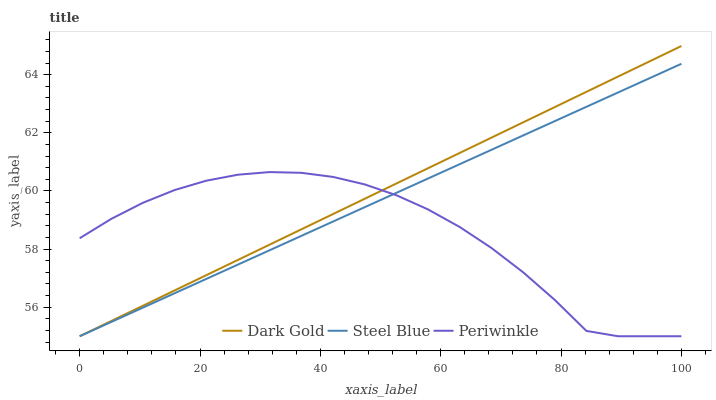Does Periwinkle have the minimum area under the curve?
Answer yes or no. Yes. Does Dark Gold have the maximum area under the curve?
Answer yes or no. Yes. Does Steel Blue have the minimum area under the curve?
Answer yes or no. No. Does Steel Blue have the maximum area under the curve?
Answer yes or no. No. Is Steel Blue the smoothest?
Answer yes or no. Yes. Is Periwinkle the roughest?
Answer yes or no. Yes. Is Dark Gold the smoothest?
Answer yes or no. No. Is Dark Gold the roughest?
Answer yes or no. No. Does Periwinkle have the lowest value?
Answer yes or no. Yes. Does Dark Gold have the highest value?
Answer yes or no. Yes. Does Steel Blue have the highest value?
Answer yes or no. No. Does Periwinkle intersect Steel Blue?
Answer yes or no. Yes. Is Periwinkle less than Steel Blue?
Answer yes or no. No. Is Periwinkle greater than Steel Blue?
Answer yes or no. No. 